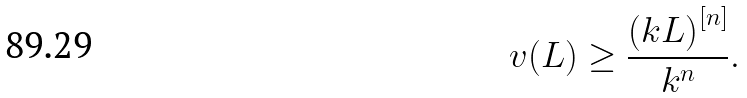Convert formula to latex. <formula><loc_0><loc_0><loc_500><loc_500>v ( L ) \geq \frac { \left ( k L \right ) ^ { [ n ] } } { k ^ { n } } .</formula> 